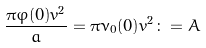Convert formula to latex. <formula><loc_0><loc_0><loc_500><loc_500>\frac { \pi \varphi ( 0 ) v ^ { 2 } } { a } = \pi \nu _ { 0 } ( 0 ) v ^ { 2 } \colon = A</formula> 